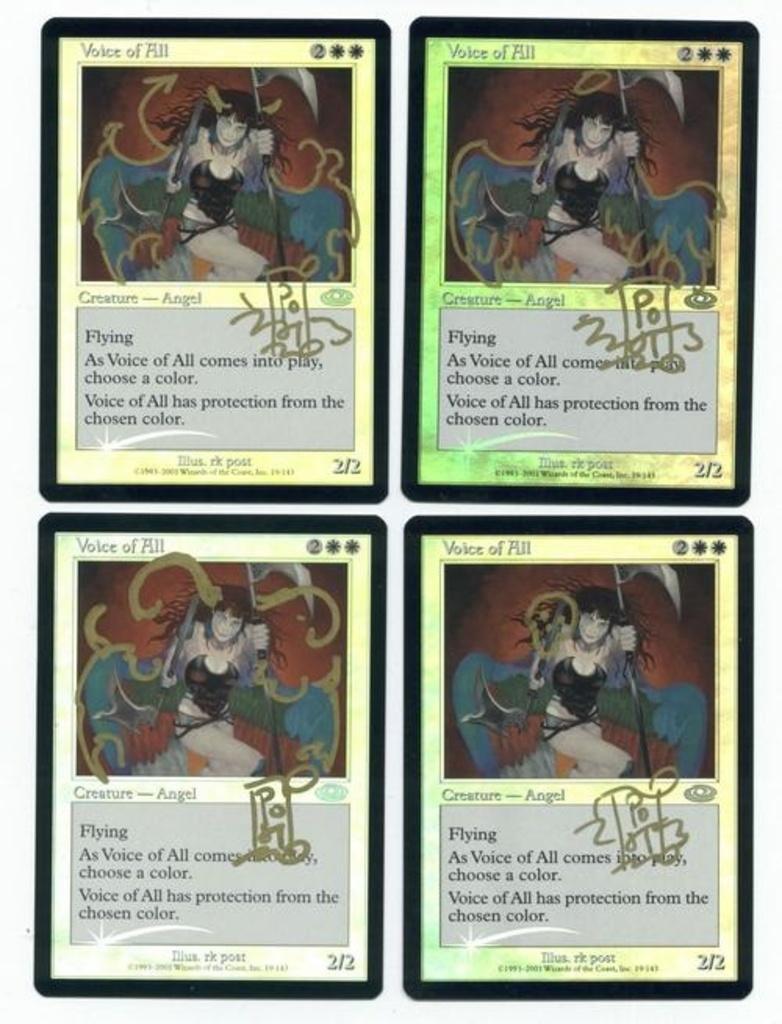Can you describe this image briefly? In this image we can see cards. In this cards there are animated images and something is written. 